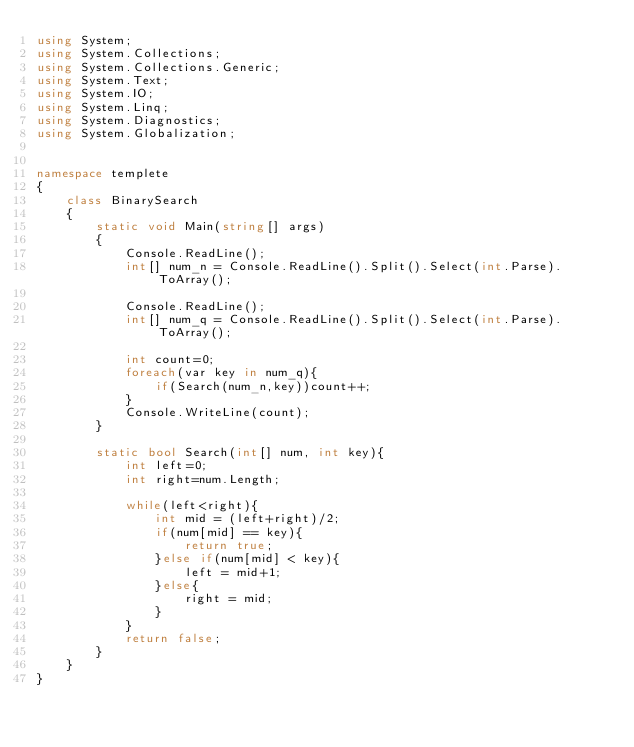<code> <loc_0><loc_0><loc_500><loc_500><_C#_>using System;
using System.Collections;
using System.Collections.Generic;
using System.Text;
using System.IO;
using System.Linq;
using System.Diagnostics;
using System.Globalization;


namespace templete
{
    class BinarySearch
    {
        static void Main(string[] args)
        {
            Console.ReadLine();
            int[] num_n = Console.ReadLine().Split().Select(int.Parse).ToArray();

            Console.ReadLine();
            int[] num_q = Console.ReadLine().Split().Select(int.Parse).ToArray();

            int count=0;
            foreach(var key in num_q){
                if(Search(num_n,key))count++;
            }
            Console.WriteLine(count);
        }

        static bool Search(int[] num, int key){
            int left=0;
            int right=num.Length;

            while(left<right){
                int mid = (left+right)/2;
                if(num[mid] == key){
                    return true;
                }else if(num[mid] < key){
                    left = mid+1;
                }else{
                    right = mid;
                }
            }
            return false;
        }
    }
}
</code> 